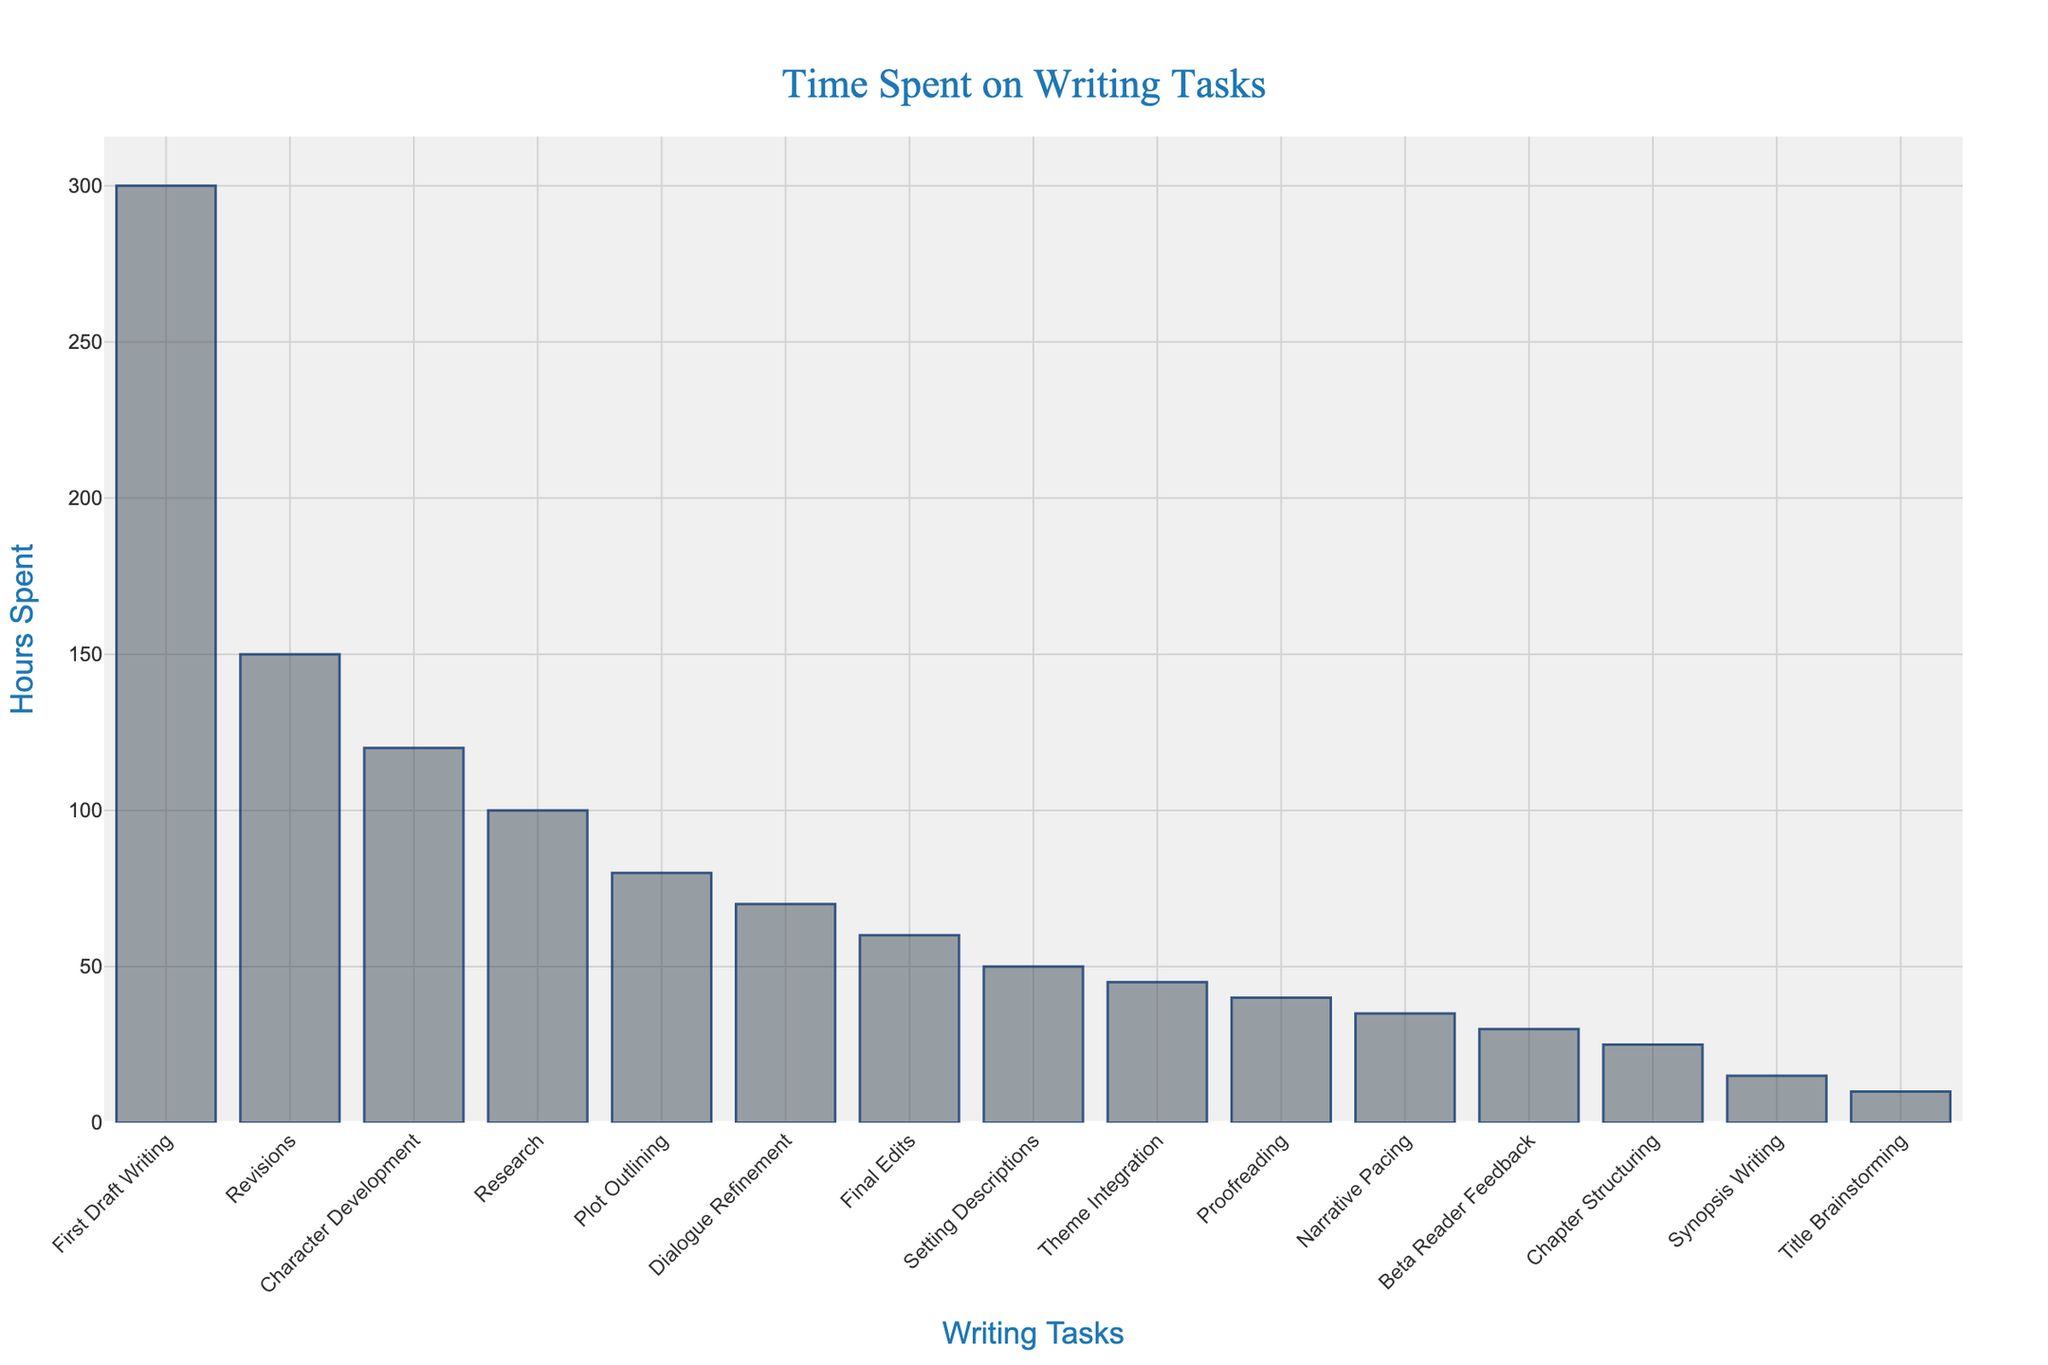What's the title of the plot? The title of the plot is positioned at the top center of the figure. By reading the text there, we can see it clearly.
Answer: "Time Spent on Writing Tasks" Which writing task has the highest number of hours spent? By analyzing the heights of the bars, we can see that the highest bar represents First Draft Writing.
Answer: First Draft Writing How many hours are spent on Research and Revisions combined? Locate the bars for Research and Revisions, then add the hours from each: Research is 100 hours and Revisions is 150 hours. Summing them gives 100 + 150.
Answer: 250 What is the average time spent on Dialogue Refinement, Setting Descriptions, and Proofreading? Find the hours for Dialogue Refinement (70), Setting Descriptions (50), and Proofreading (40). Add these values: 70 + 50 + 40 = 160. Then, divide by the number of tasks (3): 160 / 3.
Answer: Approximately 53.33 Which task has fewer hours spent, Chapter Structuring or Narrative Pacing? Compare the heights of the bars for Chapter Structuring and Narrative Pacing. Chapter Structuring has 25 hours while Narrative Pacing has 35 hours.
Answer: Chapter Structuring How much more time is spent on Character Development compared to Plot Outlining? Find the bars for Character Development (120 hours) and Plot Outlining (80 hours). Compute the difference: 120 - 80.
Answer: 40 What is the total number of hours spent on tasks with less than 50 hours each? Identify tasks with fewer than 50 hours: Proofreading (40), Beta Reader Feedback (30), Title Brainstorming (10), Synopsis Writing (15), and Chapter Structuring (25). Sum them: 40 + 30 + 10 + 15 + 25.
Answer: 120 What's the total time spent on more than 50 hours tasks? Identify tasks with more than 50 hours: Character Development (120), Plot Outlining (80), Research (100), First Draft Writing (300), Revisions (150), Dialogue Refinement (70), and Setting Descriptions (50). Sum their times: 120 + 80 + 100 + 300 + 150 + 70 + 50.
Answer: 870 